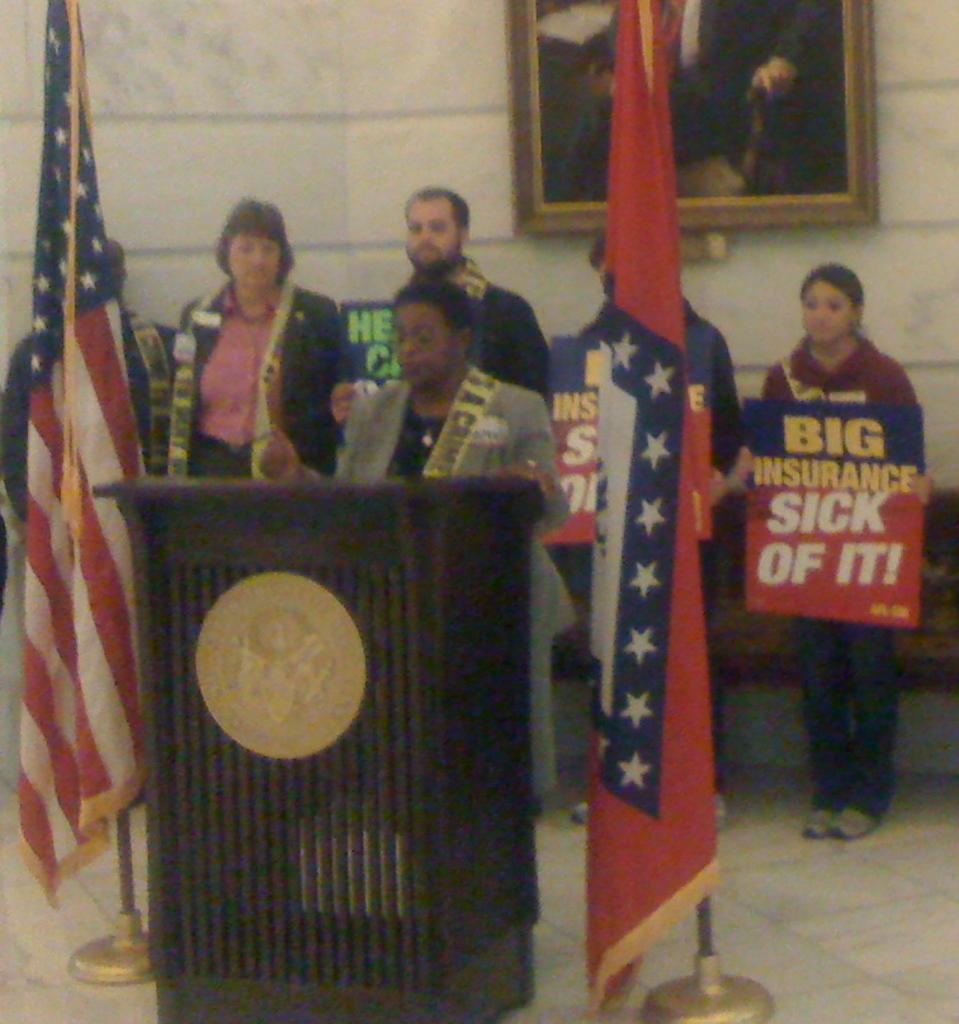<image>
Provide a brief description of the given image. A woman stands at a podium flanked by flags, while people stand behind her holding signs such as Big Insurance Sick of It! 